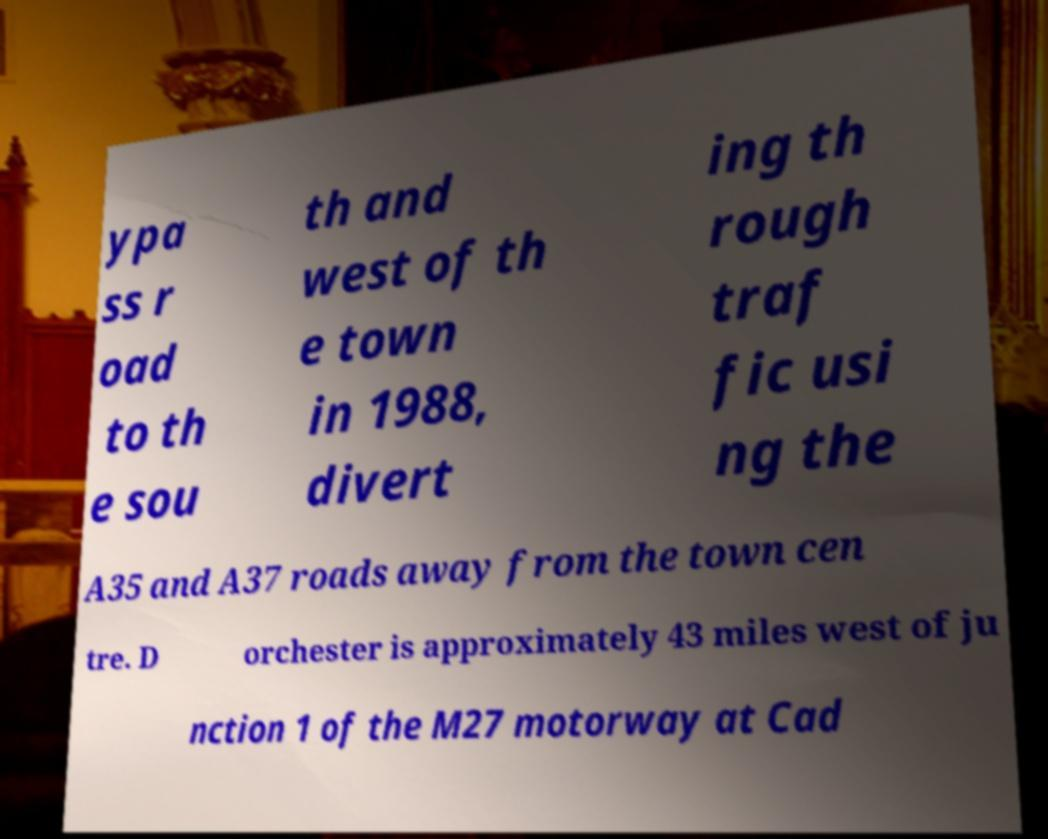For documentation purposes, I need the text within this image transcribed. Could you provide that? ypa ss r oad to th e sou th and west of th e town in 1988, divert ing th rough traf fic usi ng the A35 and A37 roads away from the town cen tre. D orchester is approximately 43 miles west of ju nction 1 of the M27 motorway at Cad 